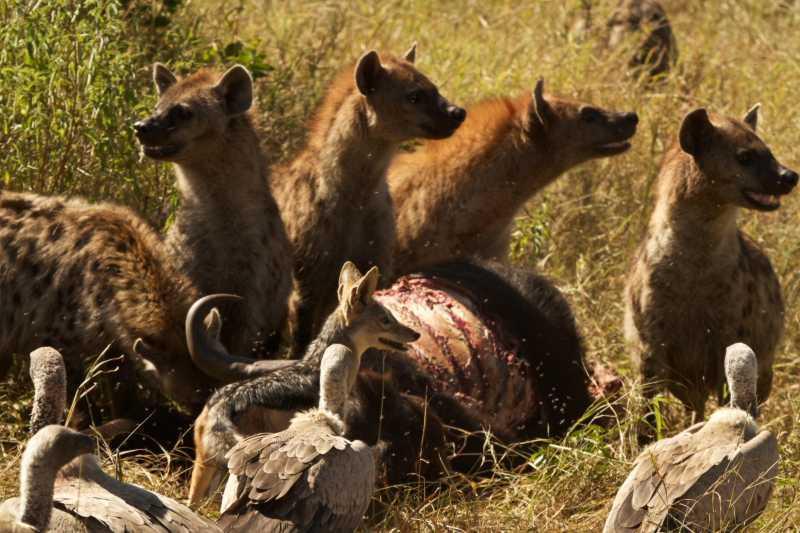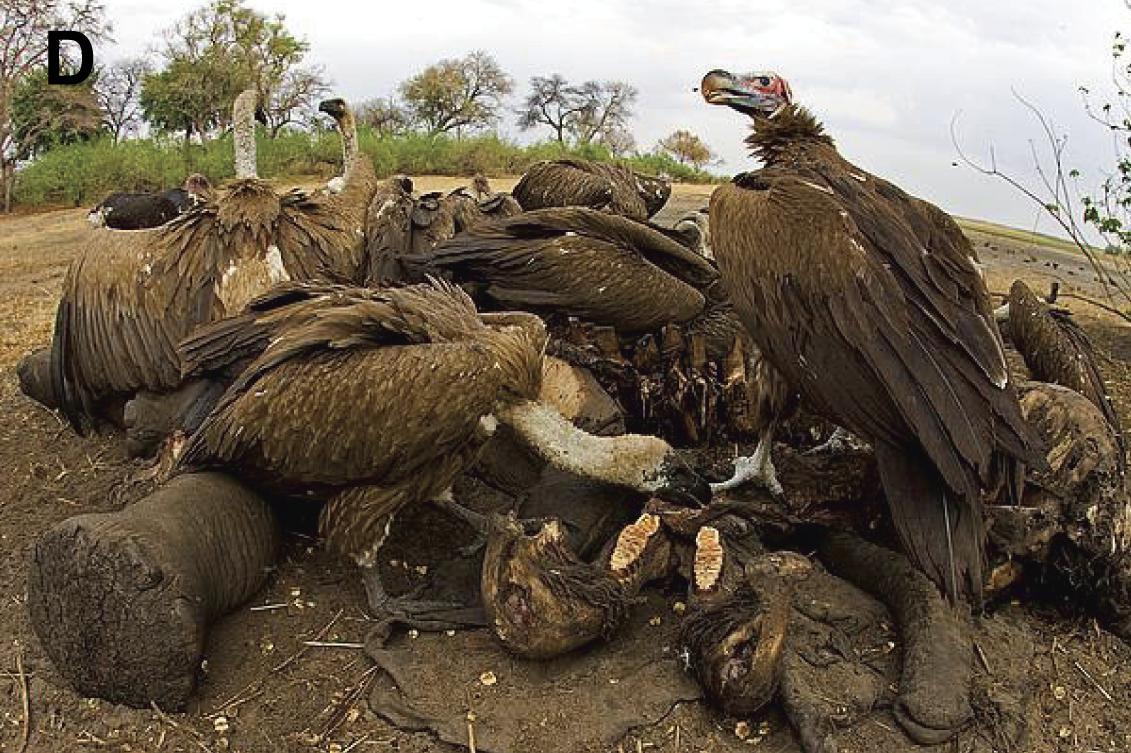The first image is the image on the left, the second image is the image on the right. Evaluate the accuracy of this statement regarding the images: "One image contains a vulture whose face is visible". Is it true? Answer yes or no. Yes. The first image is the image on the left, the second image is the image on the right. Given the left and right images, does the statement "IN at least one image there is an hyena facing left next to a small fox,vaulters and a dead animal." hold true? Answer yes or no. Yes. 